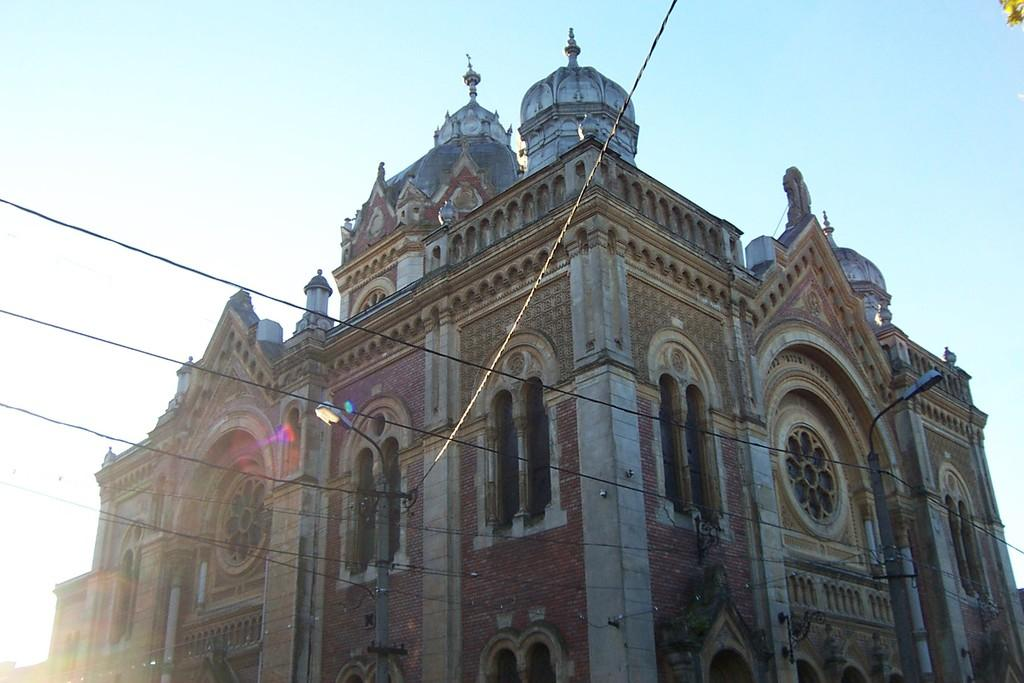What type of structure is present in the image? There is a building in the image. What other objects can be seen in the image? There are light poles and wires in the image. What is visible at the top of the image? The sky is visible at the top of the image. How many passengers are visible in the image? There are no passengers present in the image. Can you describe the rat in the image? There is no rat present in the image. 